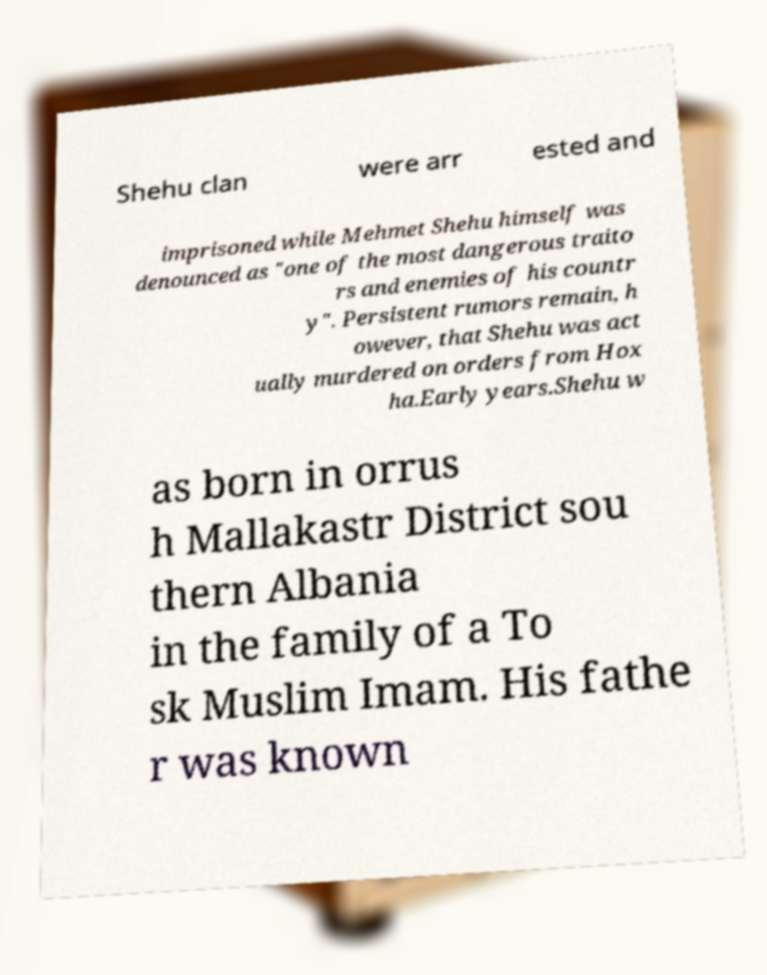I need the written content from this picture converted into text. Can you do that? Shehu clan were arr ested and imprisoned while Mehmet Shehu himself was denounced as "one of the most dangerous traito rs and enemies of his countr y". Persistent rumors remain, h owever, that Shehu was act ually murdered on orders from Hox ha.Early years.Shehu w as born in orrus h Mallakastr District sou thern Albania in the family of a To sk Muslim Imam. His fathe r was known 